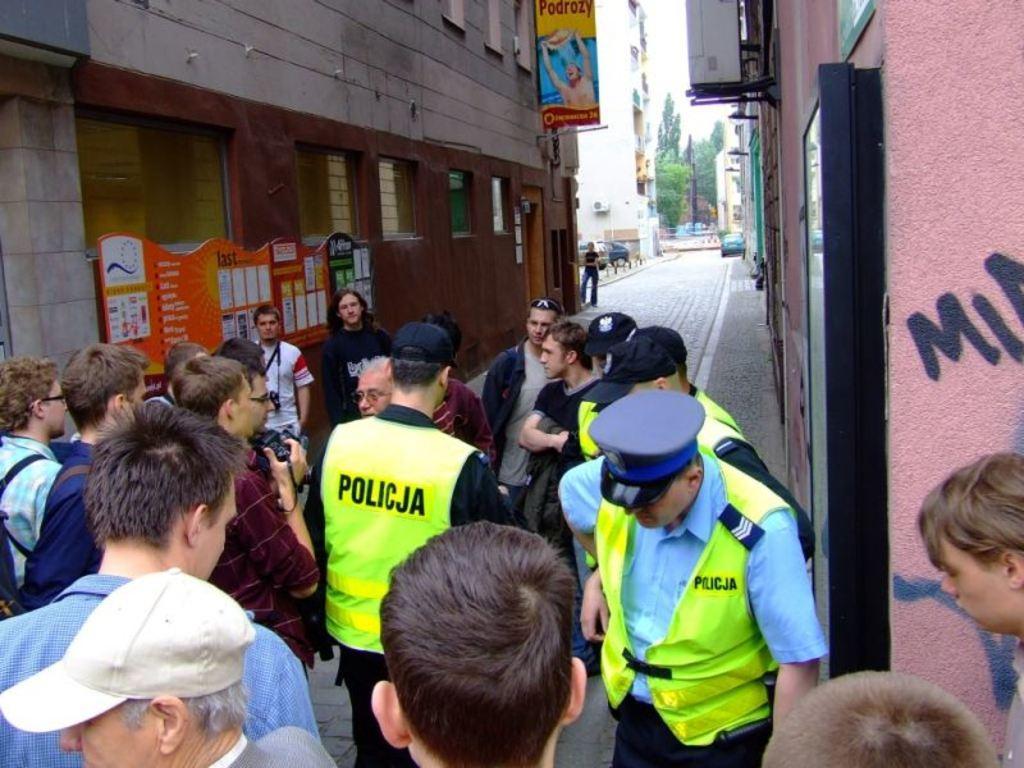Describe this image in one or two sentences. In this image I can see few people and one person is holding camera. Back I can see few buildings, windows, trees, boards and few vehicles on the road. 